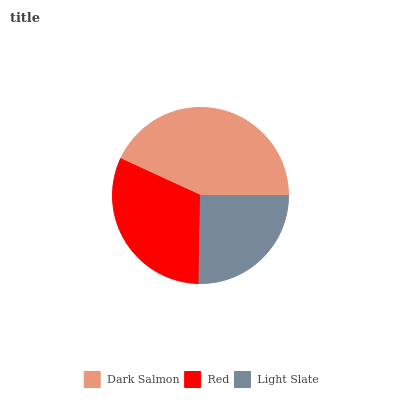Is Light Slate the minimum?
Answer yes or no. Yes. Is Dark Salmon the maximum?
Answer yes or no. Yes. Is Red the minimum?
Answer yes or no. No. Is Red the maximum?
Answer yes or no. No. Is Dark Salmon greater than Red?
Answer yes or no. Yes. Is Red less than Dark Salmon?
Answer yes or no. Yes. Is Red greater than Dark Salmon?
Answer yes or no. No. Is Dark Salmon less than Red?
Answer yes or no. No. Is Red the high median?
Answer yes or no. Yes. Is Red the low median?
Answer yes or no. Yes. Is Dark Salmon the high median?
Answer yes or no. No. Is Dark Salmon the low median?
Answer yes or no. No. 